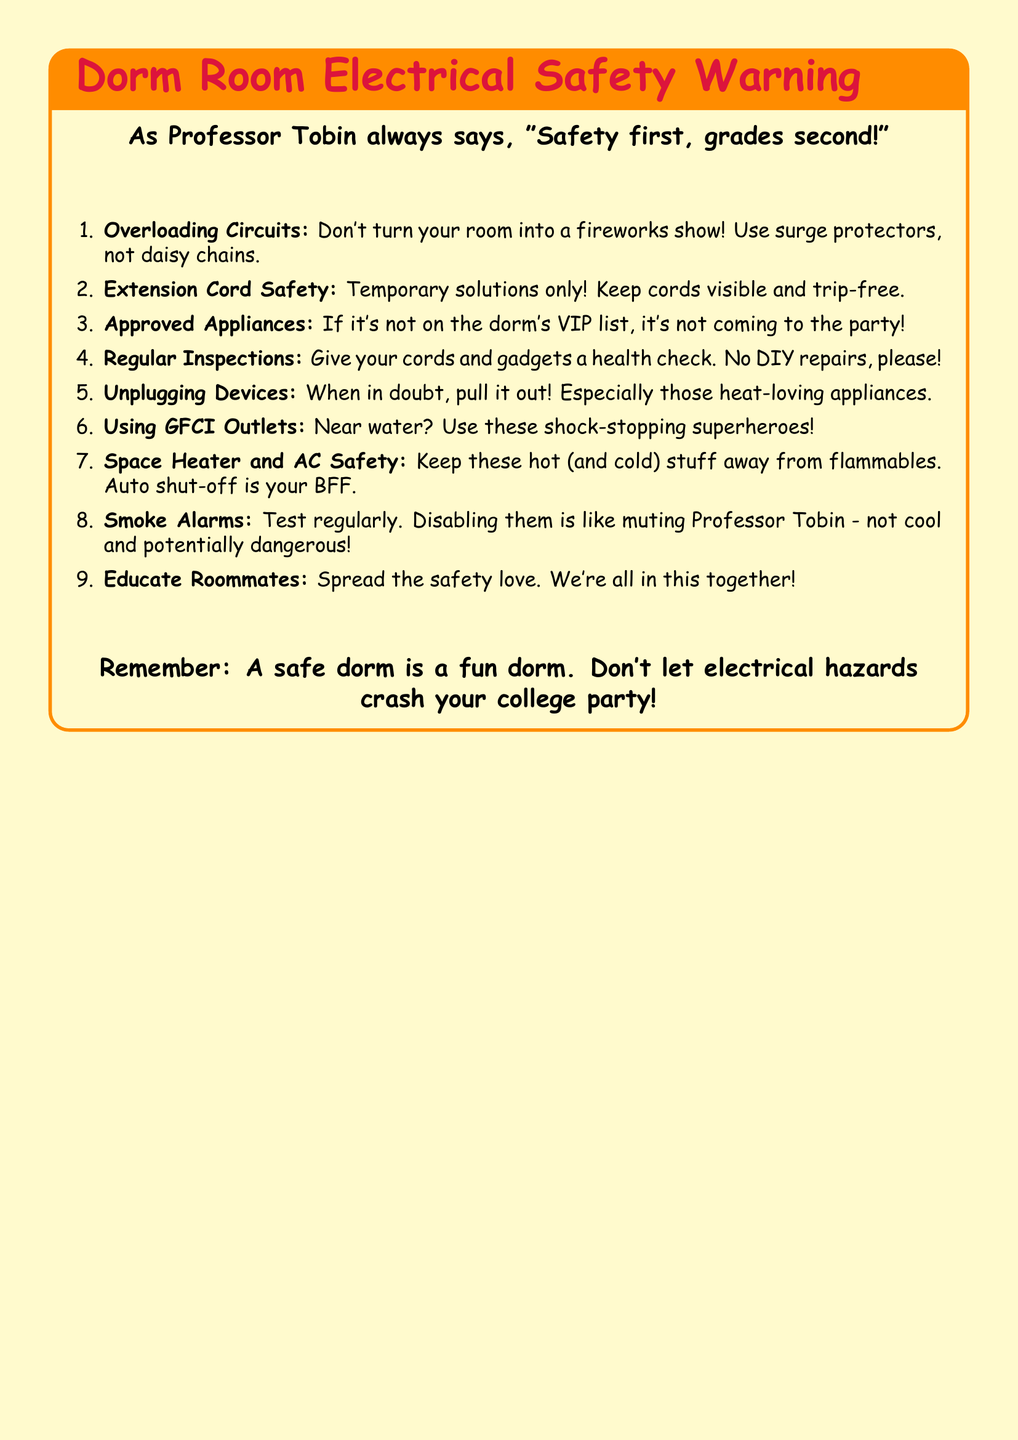What should you use instead of daisy chains? The document advises using surge protectors instead of daisy chains to prevent overloading circuits.
Answer: Surge protectors What is a tip for extension cord safety? The document highlights that extension cords are temporary solutions and advises keeping them visible and trip-free.
Answer: Keep cords visible and trip-free What should you do with heat-loving appliances? The document suggests unplugging devices when in doubt, especially those that generate heat.
Answer: Pull it out What kind of outlets should you use near water? The document recommends using GFCI outlets as a precautionary measure near water sources.
Answer: GFCI outlets How often should smoke alarms be tested? The document recommends testing smoke alarms regularly to ensure they are functioning correctly.
Answer: Regularly What is not allowed in the dorm according to the document? The document mentions that appliances not on the dorm's approved list are not allowed.
Answer: Not on the dorm's VIP list According to the document, what should you avoid doing with smoke alarms? The document indicates that disabling smoke alarms is highly discouraged, comparing it to muting a professor.
Answer: Disabling them What can you do to promote safety among roommates? The document encourages educating roommates about electrical safety to build a community of safety awareness.
Answer: Educate Roommates 